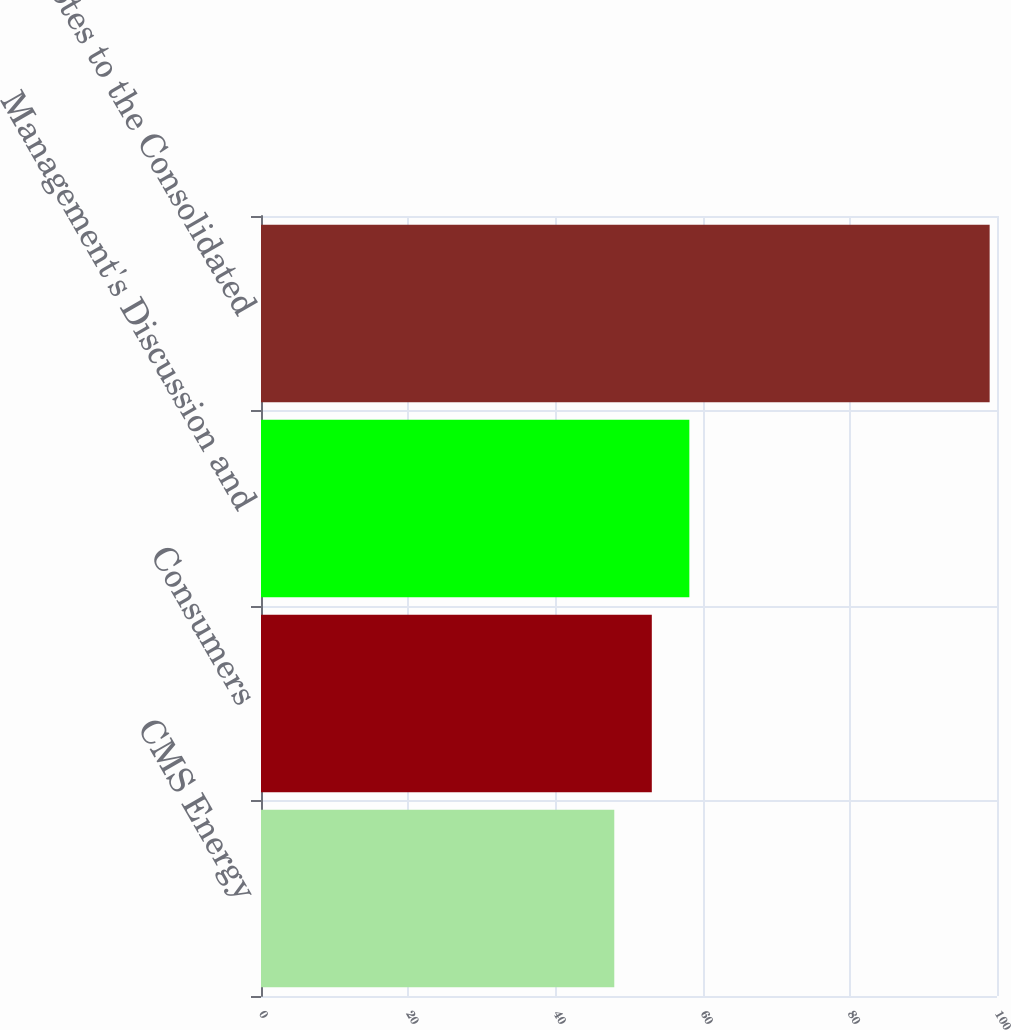<chart> <loc_0><loc_0><loc_500><loc_500><bar_chart><fcel>CMS Energy<fcel>Consumers<fcel>Management's Discussion and<fcel>Notes to the Consolidated<nl><fcel>48<fcel>53.1<fcel>58.2<fcel>99<nl></chart> 